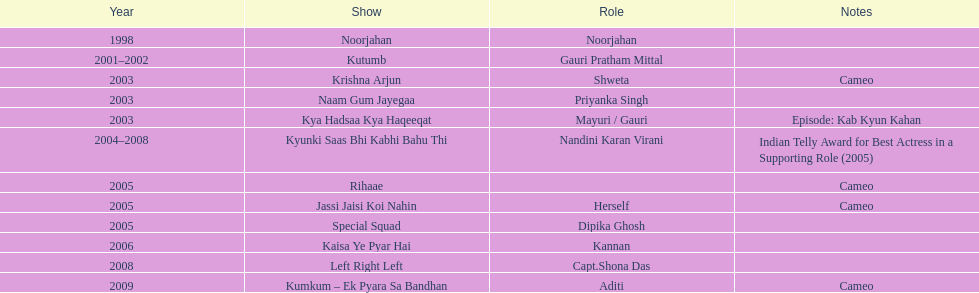In total, how many different tv series has gauri tejwani either starred or cameoed in? 11. 